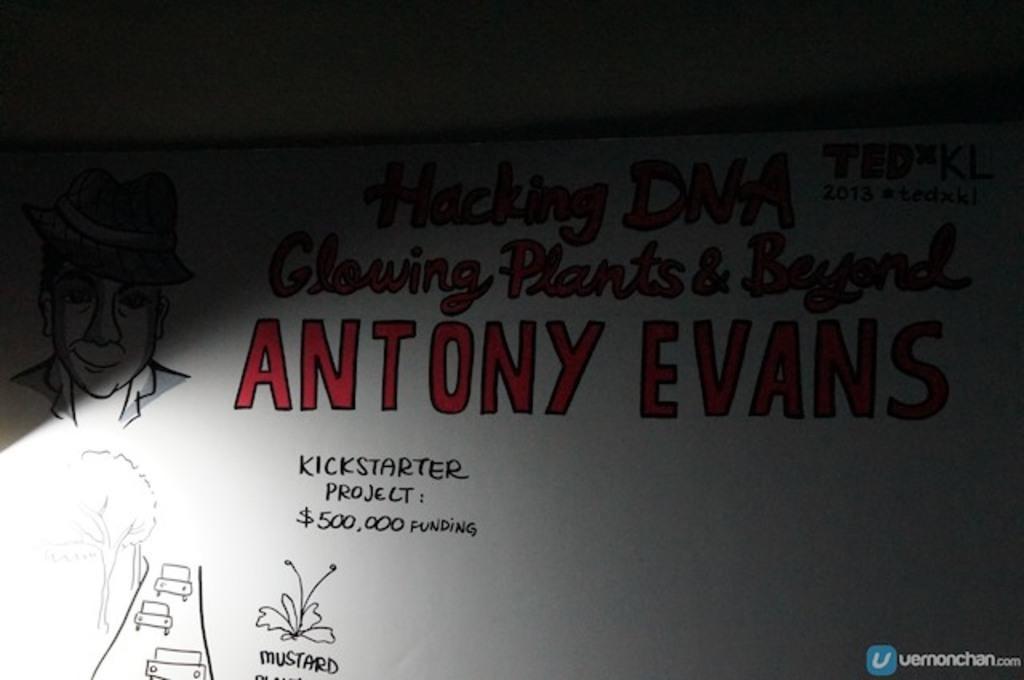How would you summarize this image in a sentence or two? This image is a drawing. To the left side of the image there is a drawing of a person. There is text at the center of the image. 